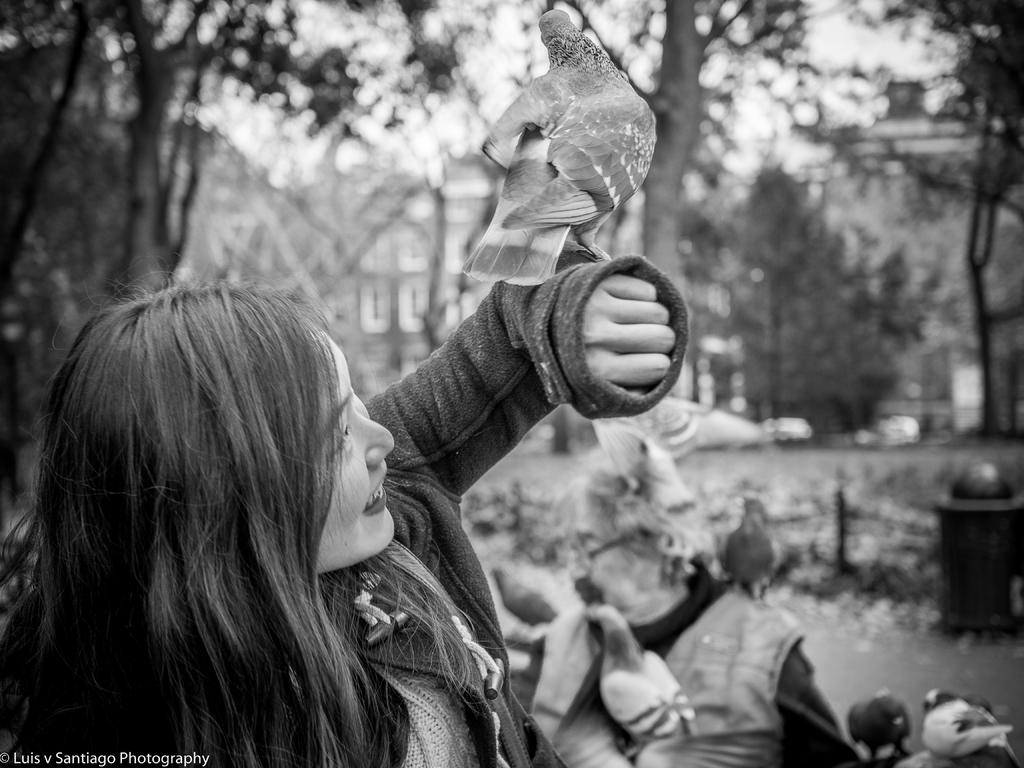What is the person in the image holding? The person is holding a bird in the image. What can be seen in the background of the image? There are trees and the sky visible in the background of the image. What is the color scheme of the image? The image is in black and white. What type of rock is being used for the machine's treatment in the image? There is no rock or machine present in the image; it features a person holding a bird. 